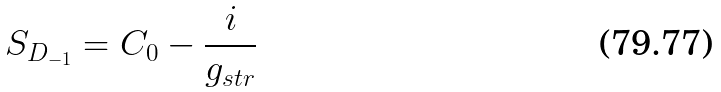Convert formula to latex. <formula><loc_0><loc_0><loc_500><loc_500>S _ { D _ { - 1 } } = C _ { 0 } - \frac { i } { g _ { s t r } }</formula> 